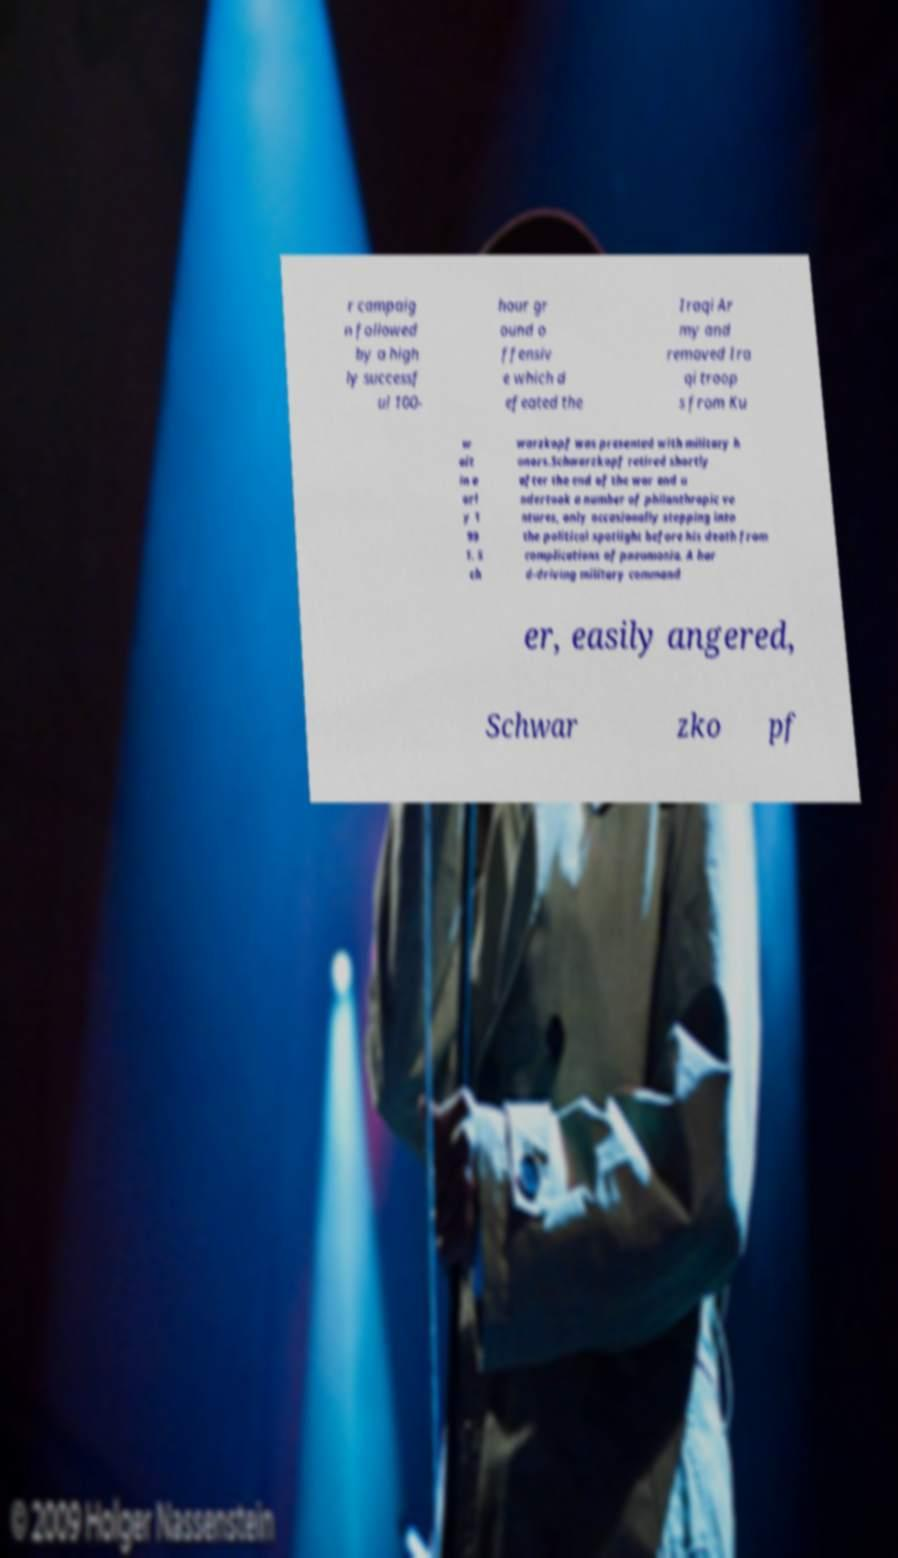Can you read and provide the text displayed in the image?This photo seems to have some interesting text. Can you extract and type it out for me? r campaig n followed by a high ly successf ul 100- hour gr ound o ffensiv e which d efeated the Iraqi Ar my and removed Ira qi troop s from Ku w ait in e arl y 1 99 1. S ch warzkopf was presented with military h onors.Schwarzkopf retired shortly after the end of the war and u ndertook a number of philanthropic ve ntures, only occasionally stepping into the political spotlight before his death from complications of pneumonia. A har d-driving military command er, easily angered, Schwar zko pf 